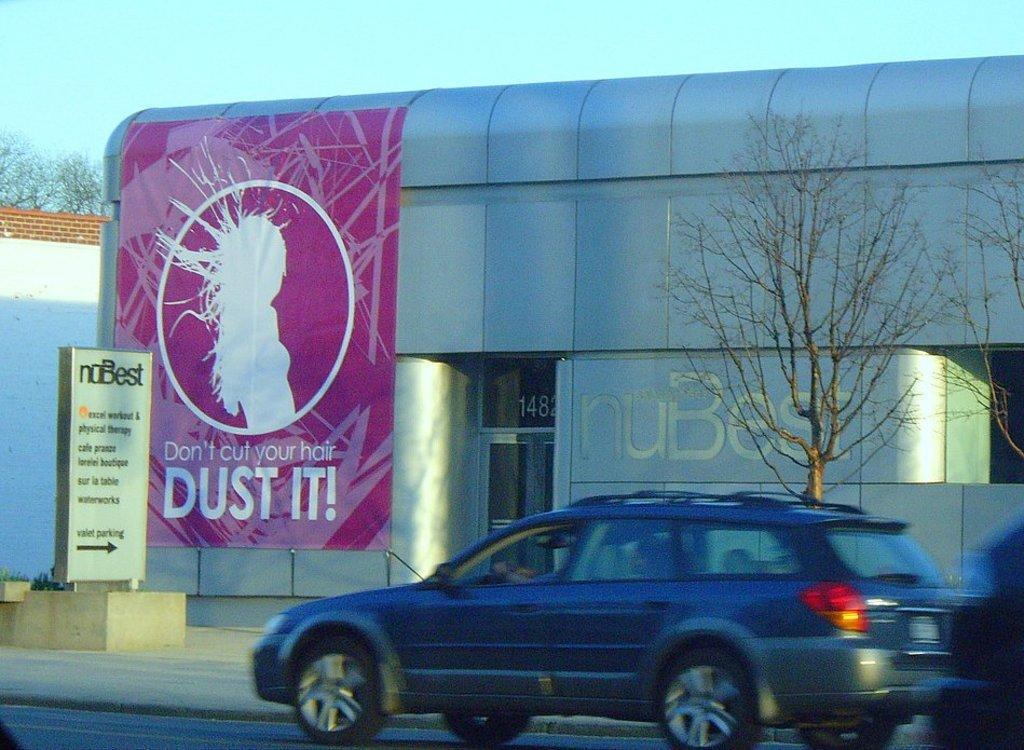Can you describe this image briefly? In the foreground of the image there is a car on the road. In the background of the image there is a building with some poster and text. There is a board with some text. There is a tree. At the top of the image there is sky. To the left side of the image there is a wall. 